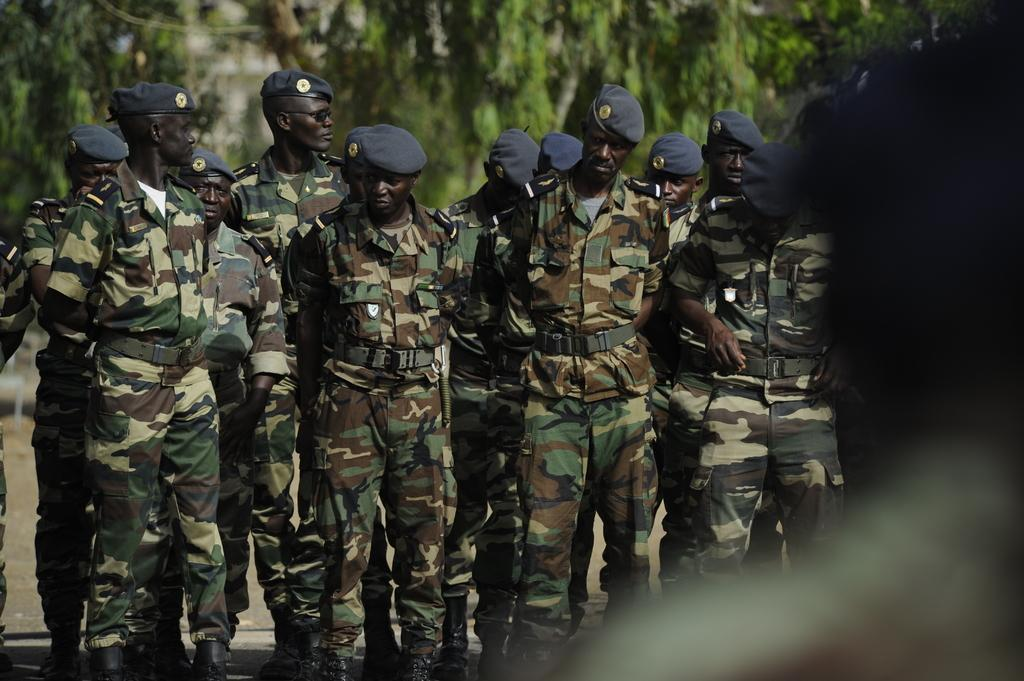What is the main subject of the image? The main subject of the image is a group of people. What are the people in the image doing? The people are standing in the image. What type of clothing are the people wearing? The people are wearing military dress and caps. What can be seen in the background of the image? There are trees in the background of the image. What is the condition of the right side of the image? The right side of the image has a blurred view. What is the title of the book that the people are reading in the image? There is no book present in the image, so there is no title to reference. 